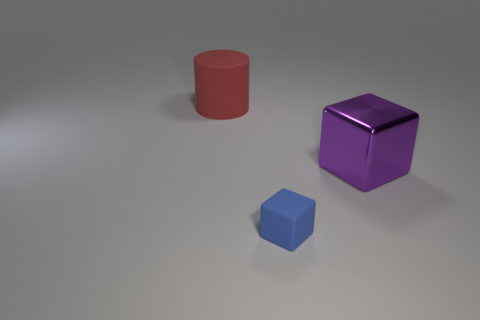Can you describe the texture and color of the objects? Certainly! The objects exhibit smooth, reflective surfaces suggesting they are made of a metallic material. The largest is a cylinder with a matte crimson hue, the medium one is a glossy cube with a purple color, and the smallest is a cube with a satin blue finish. 